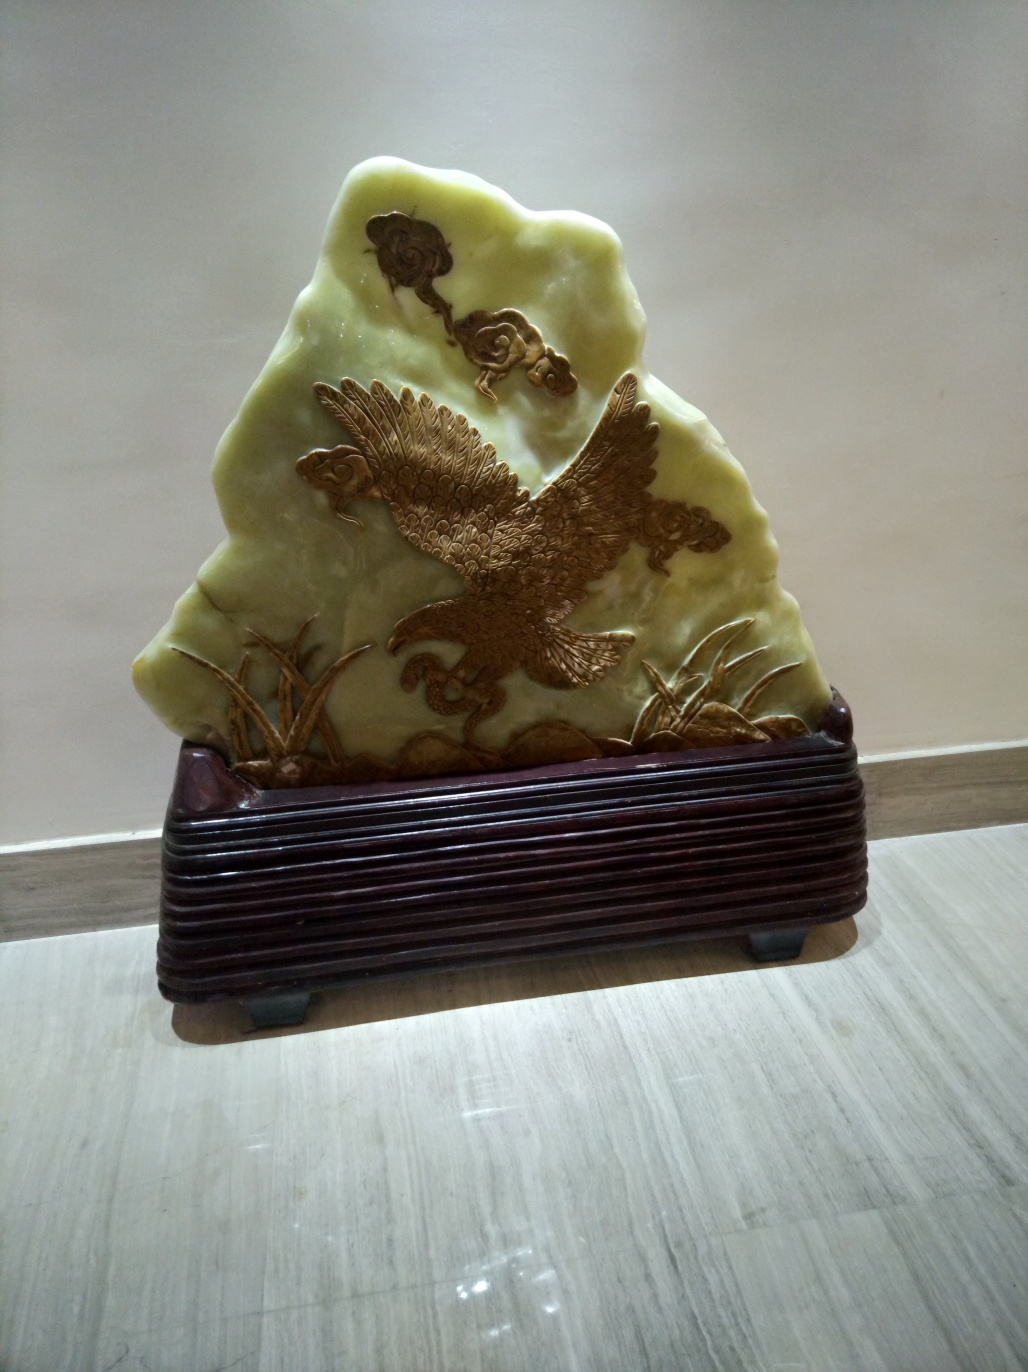Can you describe the craftsmanship of the item displayed in the image? The item in the image is a finely crafted sculpture showcasing a high level of artistic skill. It features a detailed rendering of an eagle in flight, with texture and patterns suggesting careful carving. The surrounding flora and smaller birds are also depicted with precision, which indicates that the creator of this piece was highly proficient and paid great attention to detail. 